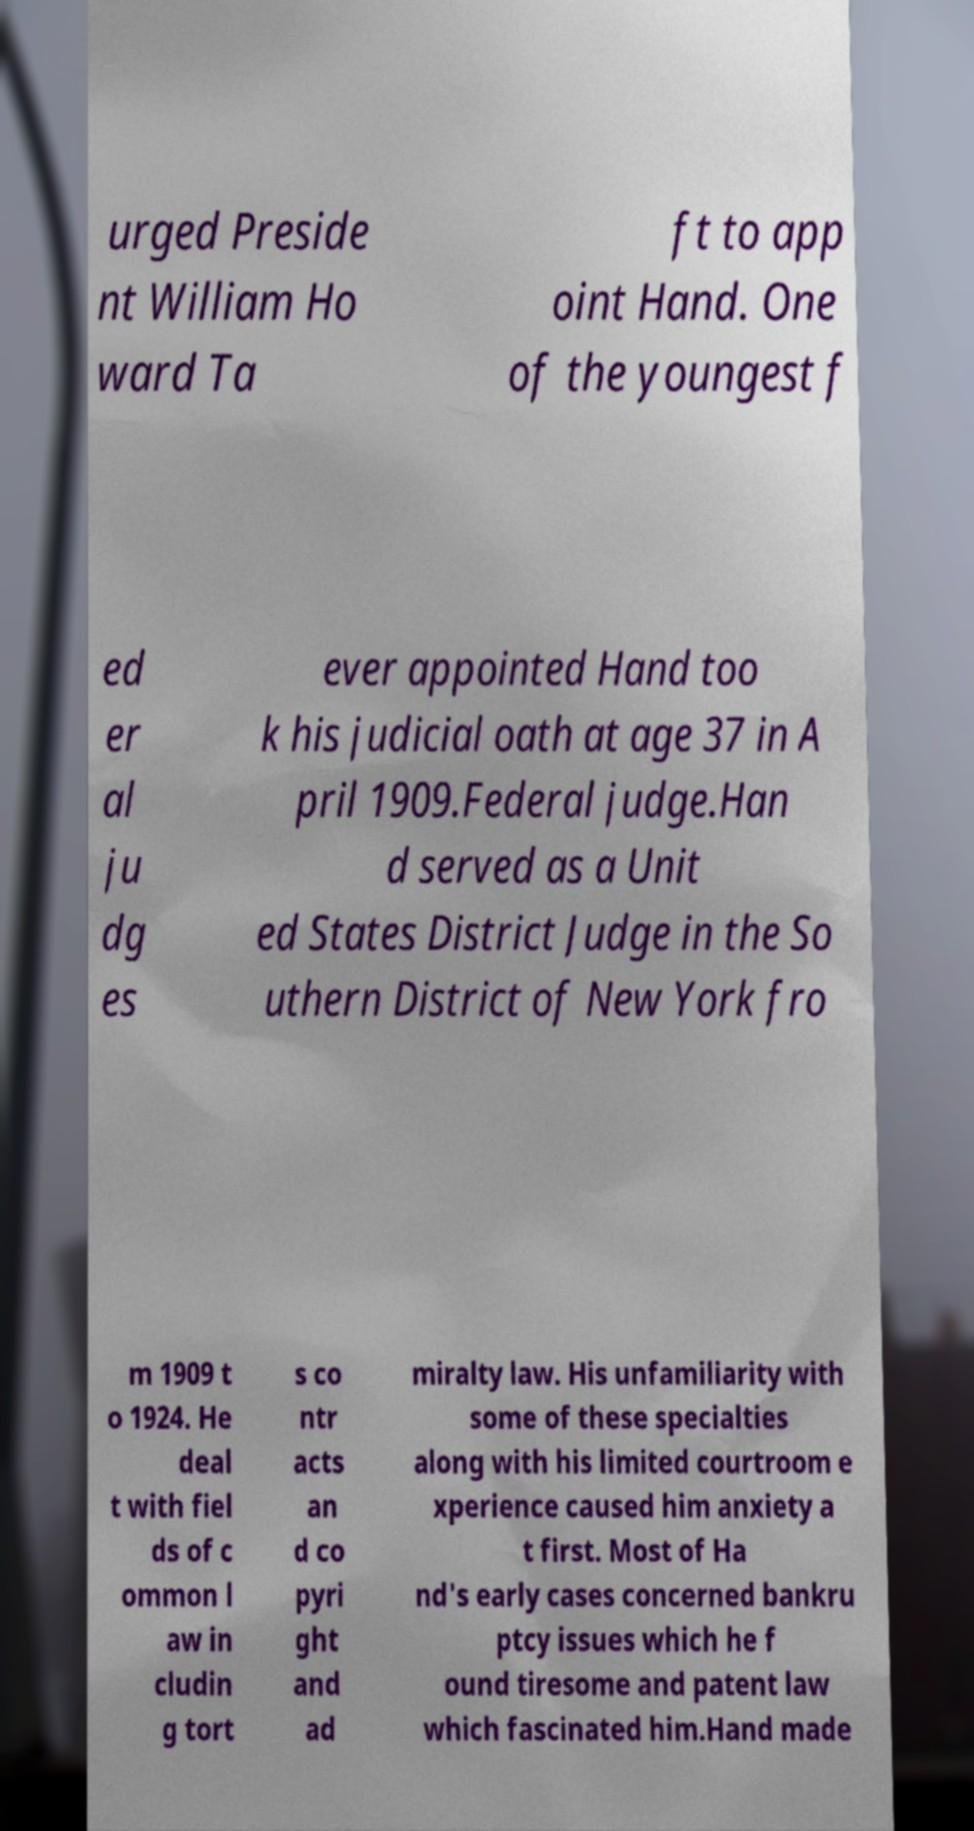Could you assist in decoding the text presented in this image and type it out clearly? urged Preside nt William Ho ward Ta ft to app oint Hand. One of the youngest f ed er al ju dg es ever appointed Hand too k his judicial oath at age 37 in A pril 1909.Federal judge.Han d served as a Unit ed States District Judge in the So uthern District of New York fro m 1909 t o 1924. He deal t with fiel ds of c ommon l aw in cludin g tort s co ntr acts an d co pyri ght and ad miralty law. His unfamiliarity with some of these specialties along with his limited courtroom e xperience caused him anxiety a t first. Most of Ha nd's early cases concerned bankru ptcy issues which he f ound tiresome and patent law which fascinated him.Hand made 